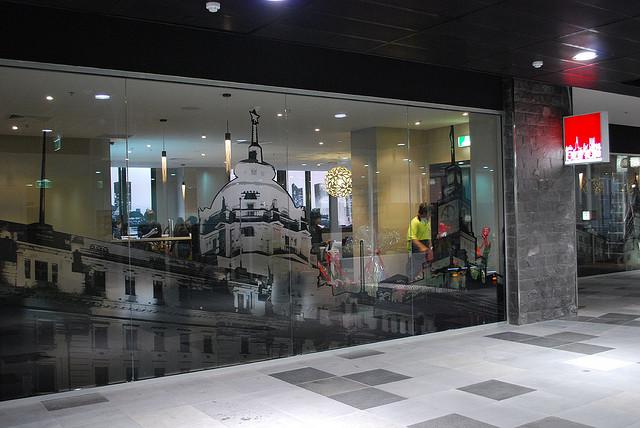Is the glass pane painted?
Short answer required. No. How many panes of glass are in this store front?
Be succinct. 1. Which store is this?
Quick response, please. Macy's. 